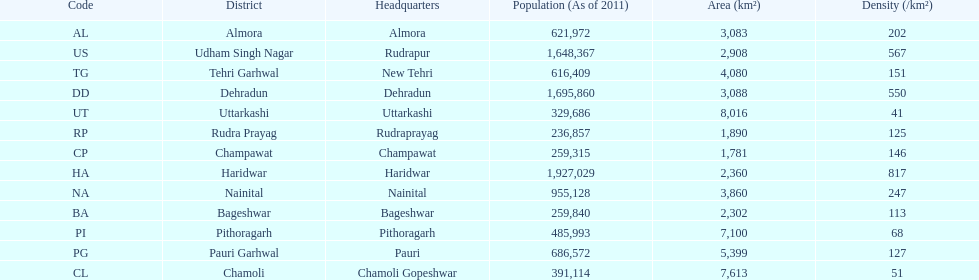Would you mind parsing the complete table? {'header': ['Code', 'District', 'Headquarters', 'Population (As of 2011)', 'Area (km²)', 'Density (/km²)'], 'rows': [['AL', 'Almora', 'Almora', '621,972', '3,083', '202'], ['US', 'Udham Singh Nagar', 'Rudrapur', '1,648,367', '2,908', '567'], ['TG', 'Tehri Garhwal', 'New Tehri', '616,409', '4,080', '151'], ['DD', 'Dehradun', 'Dehradun', '1,695,860', '3,088', '550'], ['UT', 'Uttarkashi', 'Uttarkashi', '329,686', '8,016', '41'], ['RP', 'Rudra Prayag', 'Rudraprayag', '236,857', '1,890', '125'], ['CP', 'Champawat', 'Champawat', '259,315', '1,781', '146'], ['HA', 'Haridwar', 'Haridwar', '1,927,029', '2,360', '817'], ['NA', 'Nainital', 'Nainital', '955,128', '3,860', '247'], ['BA', 'Bageshwar', 'Bageshwar', '259,840', '2,302', '113'], ['PI', 'Pithoragarh', 'Pithoragarh', '485,993', '7,100', '68'], ['PG', 'Pauri Garhwal', 'Pauri', '686,572', '5,399', '127'], ['CL', 'Chamoli', 'Chamoli Gopeshwar', '391,114', '7,613', '51']]} Tell me the number of districts with an area over 5000. 4. 